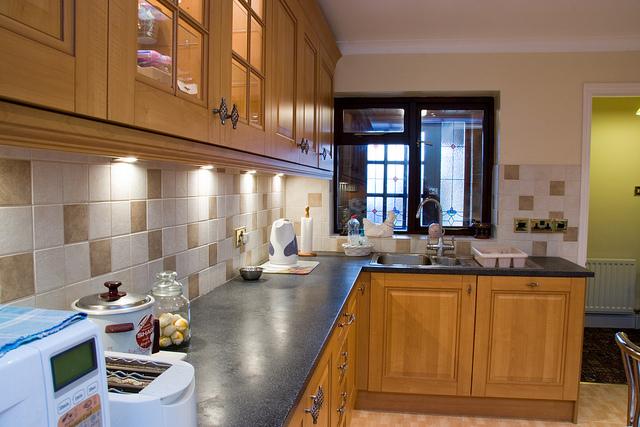What color are the kitchen cabinets?
Give a very brief answer. Brown. Is this an organized kitchen?
Concise answer only. Yes. Is this a bar?
Write a very short answer. No. Where is the lamp?
Quick response, please. Under cabinets. Can any food be seen?
Quick response, please. Yes. Is this kitchen's style modern?
Give a very brief answer. Yes. How many different colors are in the kitchen?
Be succinct. 10. 